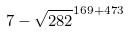Convert formula to latex. <formula><loc_0><loc_0><loc_500><loc_500>7 - \sqrt { 2 8 2 } ^ { 1 6 9 + 4 7 3 }</formula> 